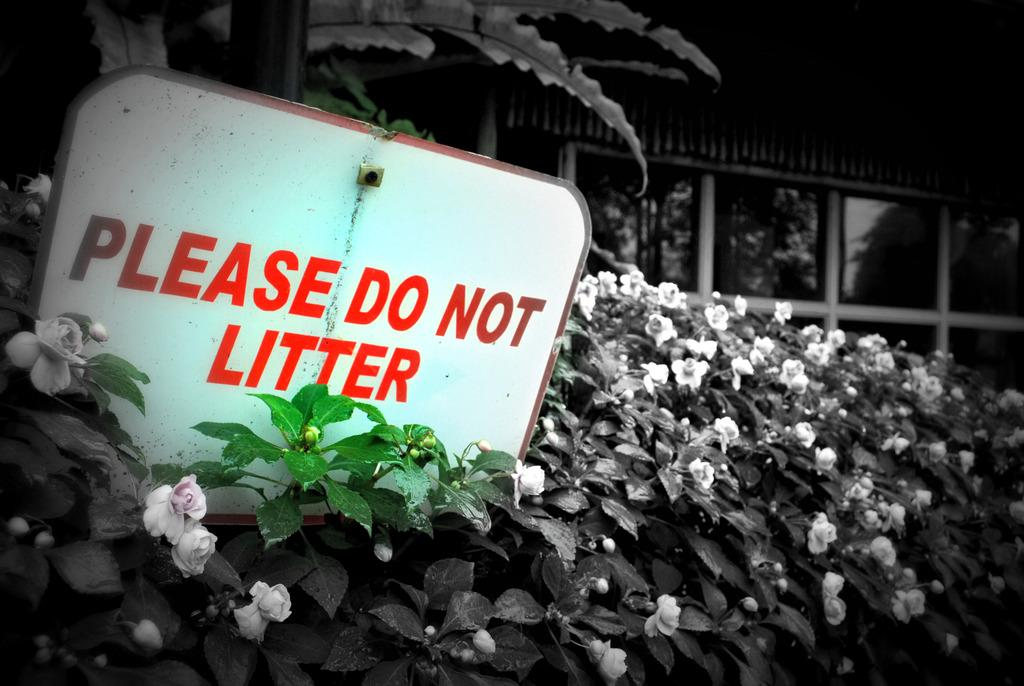What type of living organisms can be seen in the image? Plants and flowers are visible in the image. What is the tallest plant in the image? There is a tree in the image. What object can be used for displaying information or messages? There is a board in the image. What can be seen in the background of the image? Trees, a mirror, and a building are visible in the background of the image. What type of sock is hanging on the tree in the image? There is no sock present in the image; it features plants, flowers, a tree, a board, and background elements. 